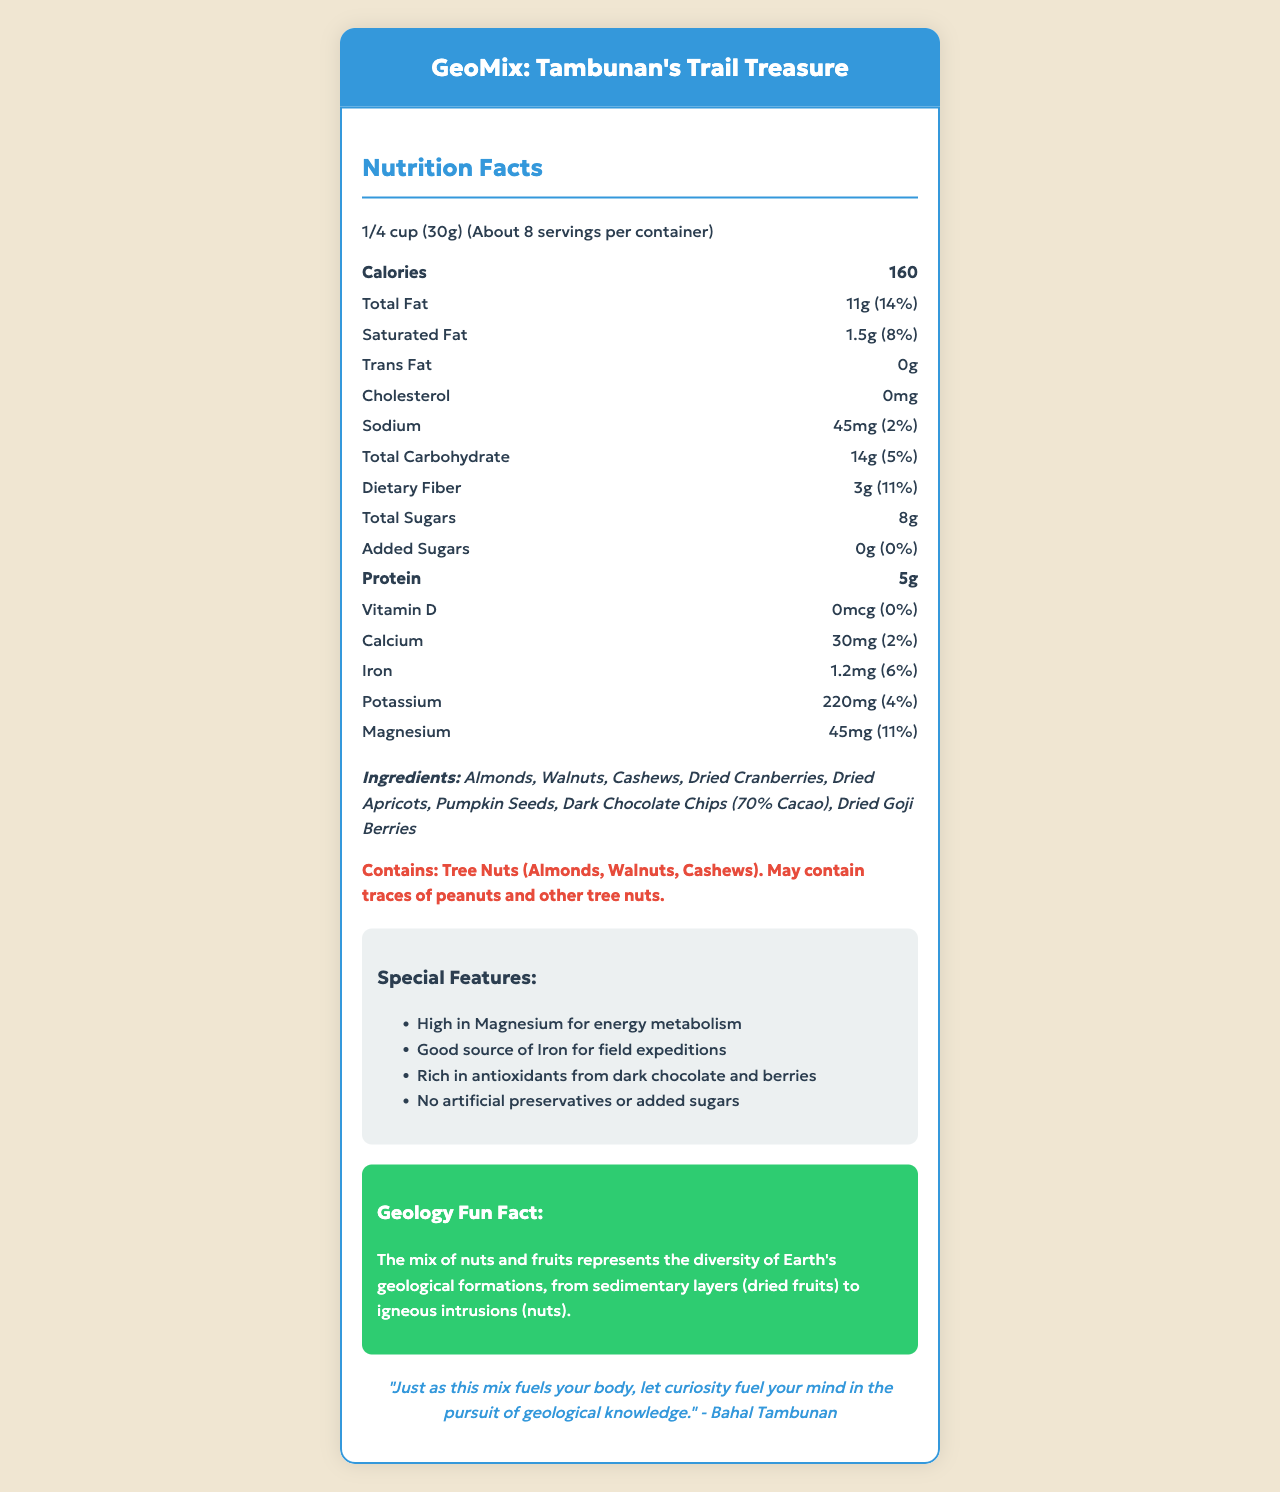what is the serving size? The serving size is stated as "1/4 cup (30g)" in the document.
Answer: 1/4 cup (30g) how many servings are in each container? The document mentions that there are "About 8" servings per container.
Answer: About 8 how many calories are there per serving? According to the document, there are "160" calories per serving.
Answer: 160 what is the amount of total fat per serving? The "Total Fat" per serving is listed as "11g".
Answer: 11g how much dietary fiber does one serving provide? The dietary fiber per serving is indicated as "3g".
Answer: 3g how much calcium is in one serving? The calcium content in one serving is "30mg".
Answer: 30mg how much protein is in a serving? The protein amount per serving is "5g".
Answer: 5g how much magnesium is in one serving? The magnesium content per serving is "45mg".
Answer: 45mg what ingredients are included in GeoMix: Tambunan’s Trail Treasure? The ingredients listed are Almonds, Walnuts, Cashews, Dried Cranberries, Dried Apricots, Pumpkin Seeds, Dark Chocolate Chips (70% Cacao), and Dried Goji Berries.
Answer: Almonds, Walnuts, Cashews, Dried Cranberries, Dried Apricots, Pumpkin Seeds, Dark Chocolate Chips (70% Cacao), Dried Goji Berries is there any cholesterol in this trail mix? The document states that there is "0mg" of cholesterol.
Answer: No how much added sugar is in one serving? The document lists the added sugars as "0g".
Answer: 0g is GeoMix safe for people with tree nut allergies? The allergen information includes "Contains: Tree Nuts (Almonds, Walnuts, Cashews). May contain traces of peanuts and other tree nuts."
Answer: No what is the geologically fun fact mentioned about the trail mix? The document includes this fun fact as part of the "Geology Fun Fact" section.
Answer: The mix of nuts and fruits represents the diversity of Earth's geological formations, from sedimentary layers (dried fruits) to igneous intrusions (nuts). what does Bahal Tambunan’s quote say? The document features this quote from Bahal Tambunan in a designated section.
Answer: "Just as this mix fuels your body, let curiosity fuel your mind in the pursuit of geological knowledge." based on the information, which nutrient is particularly high in this trail mix? The document mentions that one of the special features is "High in Magnesium for energy metabolism," and the magnesium daily value is 11%, indicating a high level of magnesium.
Answer: Magnesium which of the following does NOT contain any added sugars? A. Dried Cranberries B. Dried Apricots C. GeoMix: Tambunan's Trail Treasure D. Dark Chocolate Chips The document states that GeoMix has "0g" of added sugars.
Answer: C. GeoMix: Tambunan's Trail Treasure which nutrient contributes the least to the daily value in this mix? A. Calcium B. Iron C. Potassium D. Vitamin D The document indicates that the daily value for Vitamin D is "0%," which is the least among the listed nutrients.
Answer: D. Vitamin D is this product free of artificial preservatives? One of the special features listed is "No artificial preservatives or added sugars."
Answer: Yes summarize the main features of GeoMix: Tambunan’s Trail Treasure. This summary covers the key points including the product name, nutritional content per serving, noted health benefits, special features, symbolic meaning, and the included quote.
Answer: GeoMix: Tambunan’s Trail Treasure is a nutrient-dense trail mix designed for geologists, containing a variety of nuts and dried fruits. Its serving size is 1/4 cup (30g), with approximately 8 servings per container. Each serving has 160 calories, 11g of total fat, 3g of dietary fiber, and 5g of protein. Notable nutrients include magnesium, iron, and potassium. The product is free of artificial preservatives and added sugars, rich in antioxidants, and high in magnesium. The mix symbolizes geological formations and includes a motivational quote from Bahal Tambunan. what is the source of the flavor in this trail mix? The document does not provide specific information about the flavor sources, such as spices or sweeteners used, excluding natural flavors of the listed ingredients.
Answer: Not enough information 